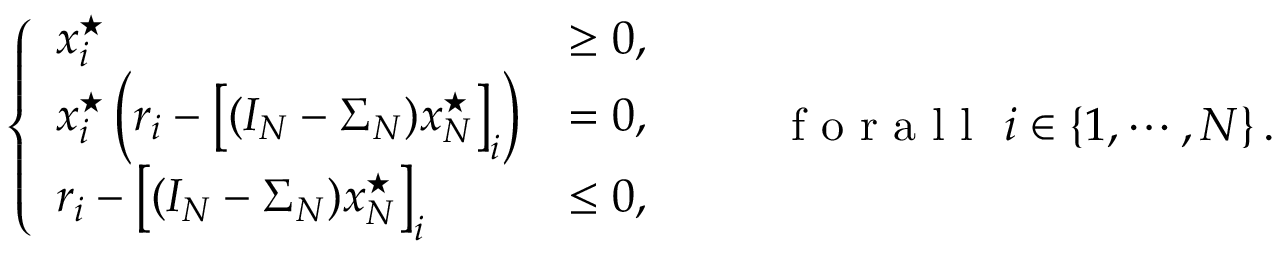<formula> <loc_0><loc_0><loc_500><loc_500>\left \{ \begin{array} { l l } { x _ { i } ^ { ^ { * } } } & { \geq 0 , } \\ { x _ { i } ^ { ^ { * } } \left ( r _ { i } - \left [ ( I _ { N } - \Sigma _ { N } ) x _ { N } ^ { ^ { * } } \right ] _ { i } \right ) } & { = 0 , } \\ { r _ { i } - \left [ ( I _ { N } - \Sigma _ { N } ) x _ { N } ^ { ^ { * } } \right ] _ { i } } & { \leq 0 , } \end{array} \quad f o r a l l \ i \in \{ 1 , \cdots , N \} \, .</formula> 